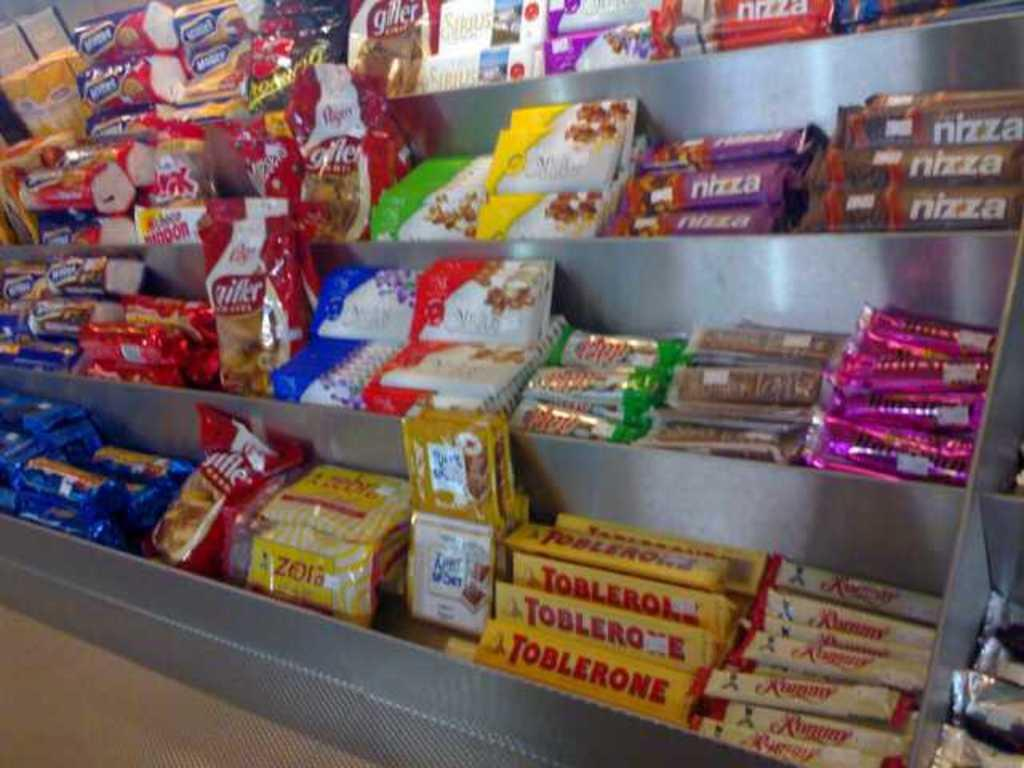<image>
Relay a brief, clear account of the picture shown. Store selling candy that include Toblerone and Nizza. 